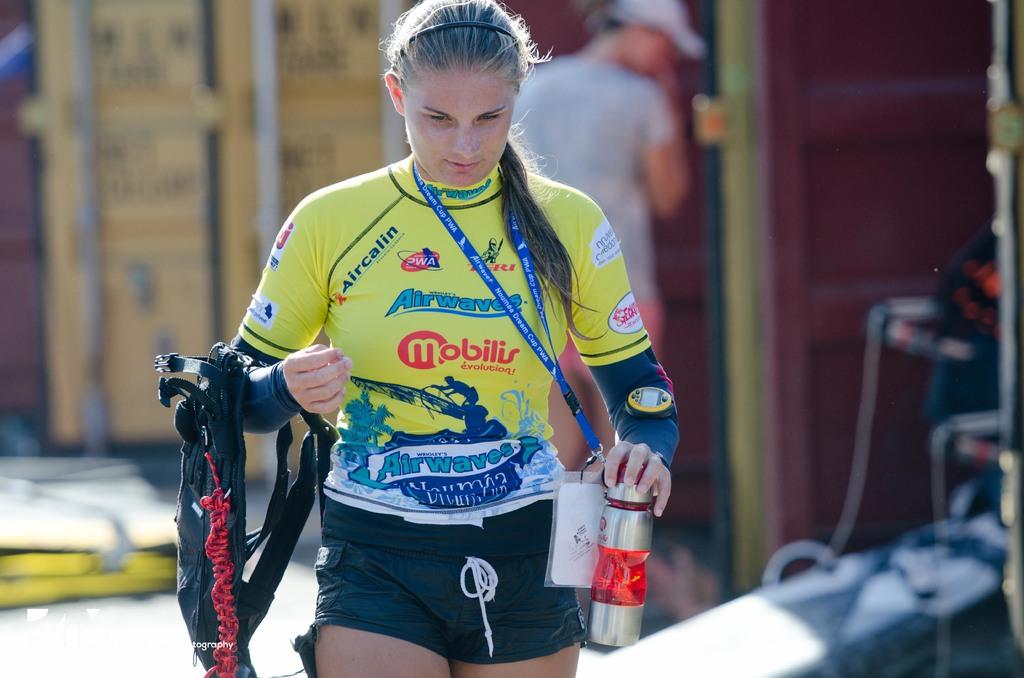What is the name of the main sponsor of this athlete?
Provide a short and direct response. Mobilis. 